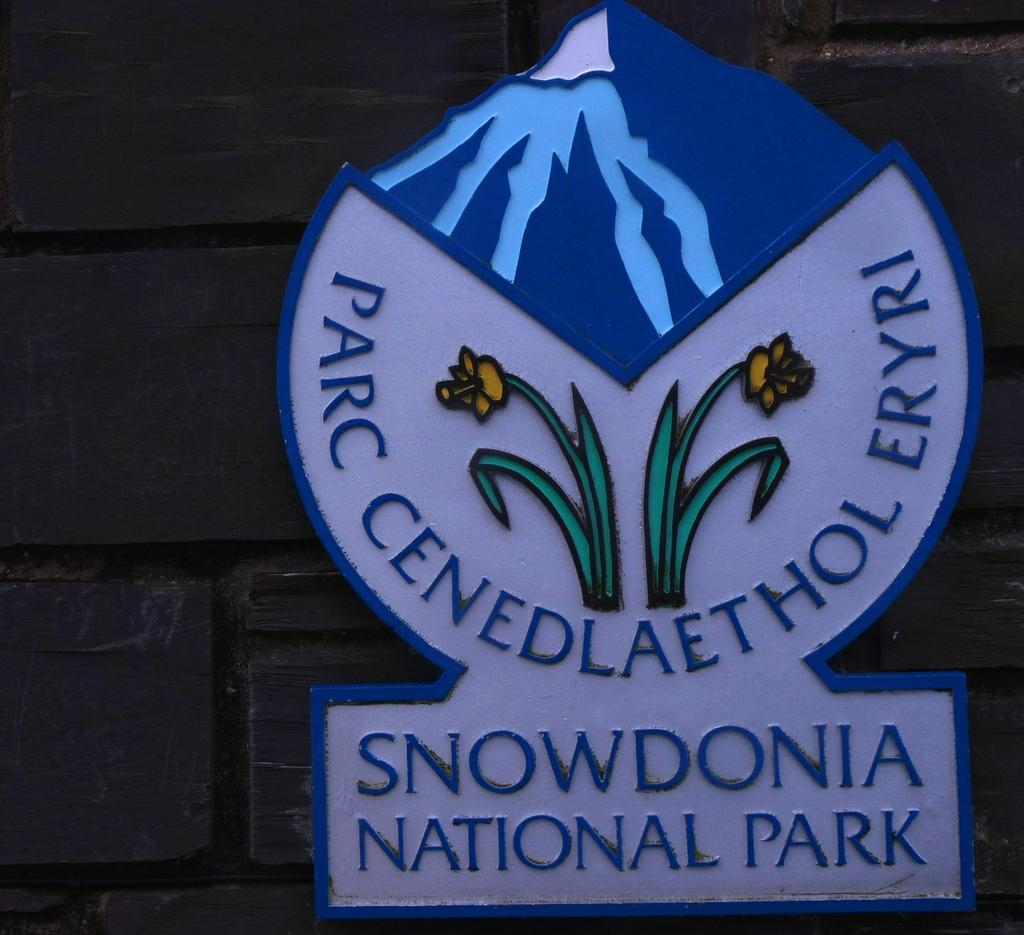What is the main object in the image? There is a board in the image. What is written or displayed on the board? The board has text on it. Is there any visual element on the board? Yes, there is an image attached to the board. How is the board positioned in the image? The board is attached to the wall. How many boys are spying on the planes in the image? There are no boys or planes present in the image; it only features a board with text and an image. 